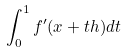<formula> <loc_0><loc_0><loc_500><loc_500>\int _ { 0 } ^ { 1 } f ^ { \prime } ( x + t h ) d t</formula> 